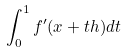<formula> <loc_0><loc_0><loc_500><loc_500>\int _ { 0 } ^ { 1 } f ^ { \prime } ( x + t h ) d t</formula> 